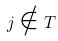Convert formula to latex. <formula><loc_0><loc_0><loc_500><loc_500>j \notin T</formula> 